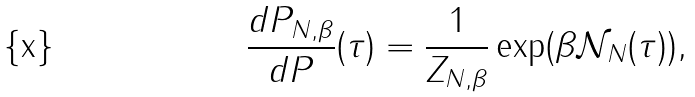Convert formula to latex. <formula><loc_0><loc_0><loc_500><loc_500>\frac { d P _ { N , \beta } } { d P } ( \tau ) = \frac { 1 } { Z _ { N , \beta } } \exp ( \beta \mathcal { N } _ { N } ( \tau ) ) ,</formula> 